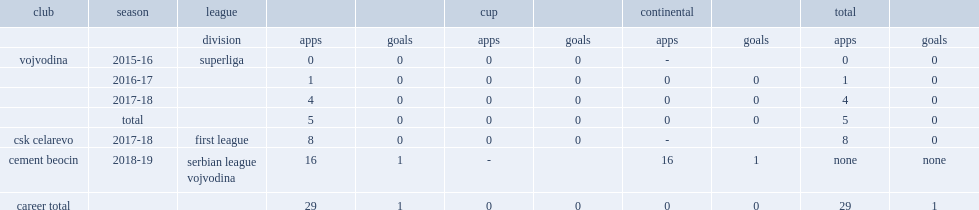Which club did zlicic play for in 2016-17? Vojvodina. 